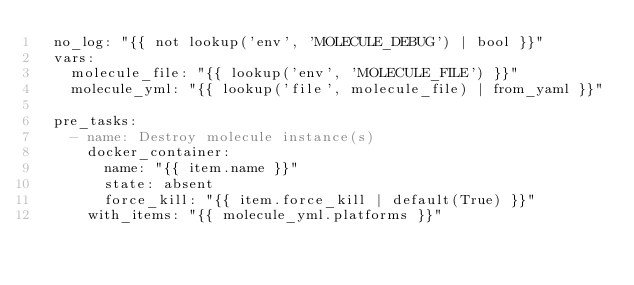Convert code to text. <code><loc_0><loc_0><loc_500><loc_500><_YAML_>  no_log: "{{ not lookup('env', 'MOLECULE_DEBUG') | bool }}"
  vars:
    molecule_file: "{{ lookup('env', 'MOLECULE_FILE') }}"
    molecule_yml: "{{ lookup('file', molecule_file) | from_yaml }}"

  pre_tasks:
    - name: Destroy molecule instance(s)
      docker_container:
        name: "{{ item.name }}"
        state: absent
        force_kill: "{{ item.force_kill | default(True) }}"
      with_items: "{{ molecule_yml.platforms }}"
</code> 